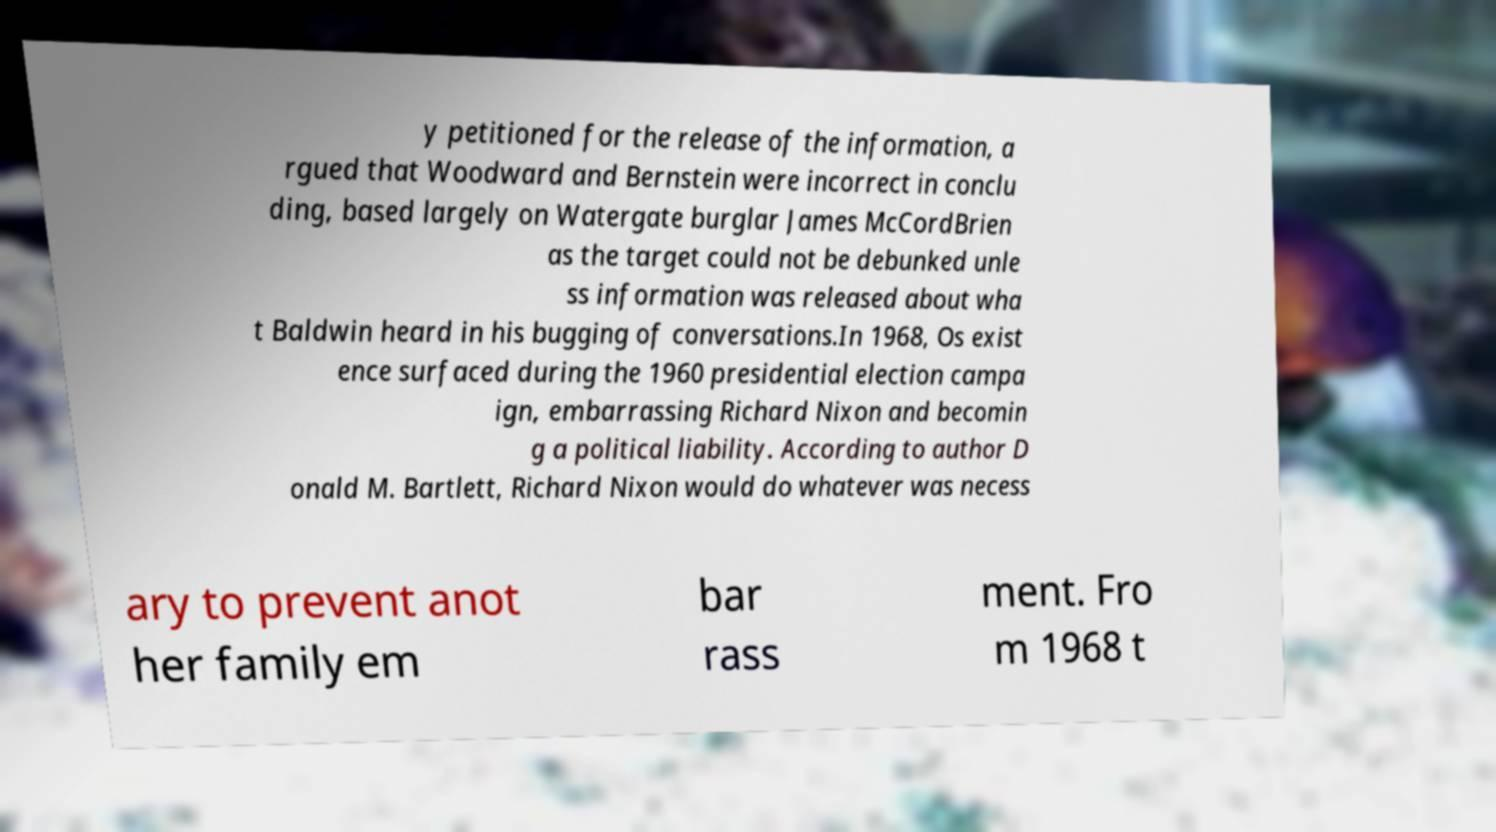I need the written content from this picture converted into text. Can you do that? y petitioned for the release of the information, a rgued that Woodward and Bernstein were incorrect in conclu ding, based largely on Watergate burglar James McCordBrien as the target could not be debunked unle ss information was released about wha t Baldwin heard in his bugging of conversations.In 1968, Os exist ence surfaced during the 1960 presidential election campa ign, embarrassing Richard Nixon and becomin g a political liability. According to author D onald M. Bartlett, Richard Nixon would do whatever was necess ary to prevent anot her family em bar rass ment. Fro m 1968 t 